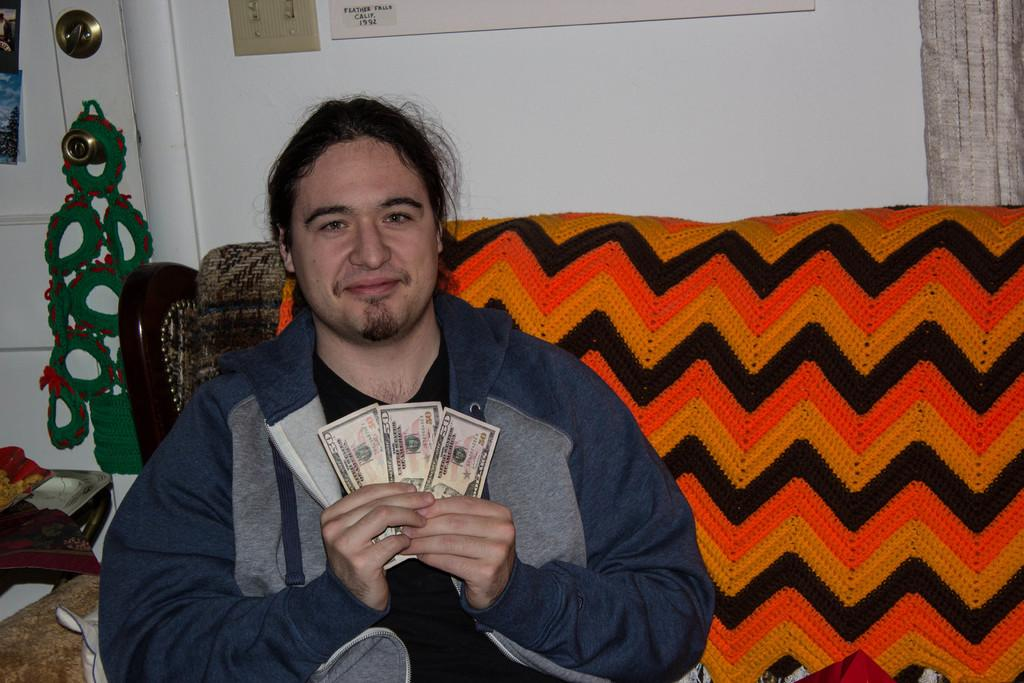Who is present in the image? There is a man in the image. What is the man doing in the image? The man is sitting on a sofa. What is the man holding in his hand? The man is holding money in his hand. What can be seen in the background of the image? There is a wall in the background of the image. What type of mark can be seen on the man's throat in the image? There is no mark visible on the man's throat in the image. How many times has the man folded the money in the image? There is no indication in the image that the man has folded the money. 